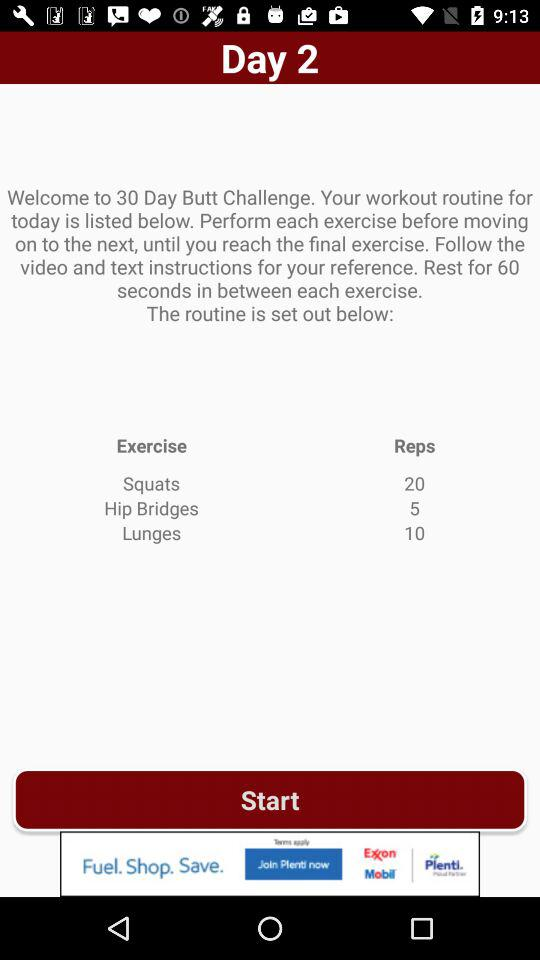What is the resting time in between each exercise? The resting time in between each exercise is 60 seconds. 